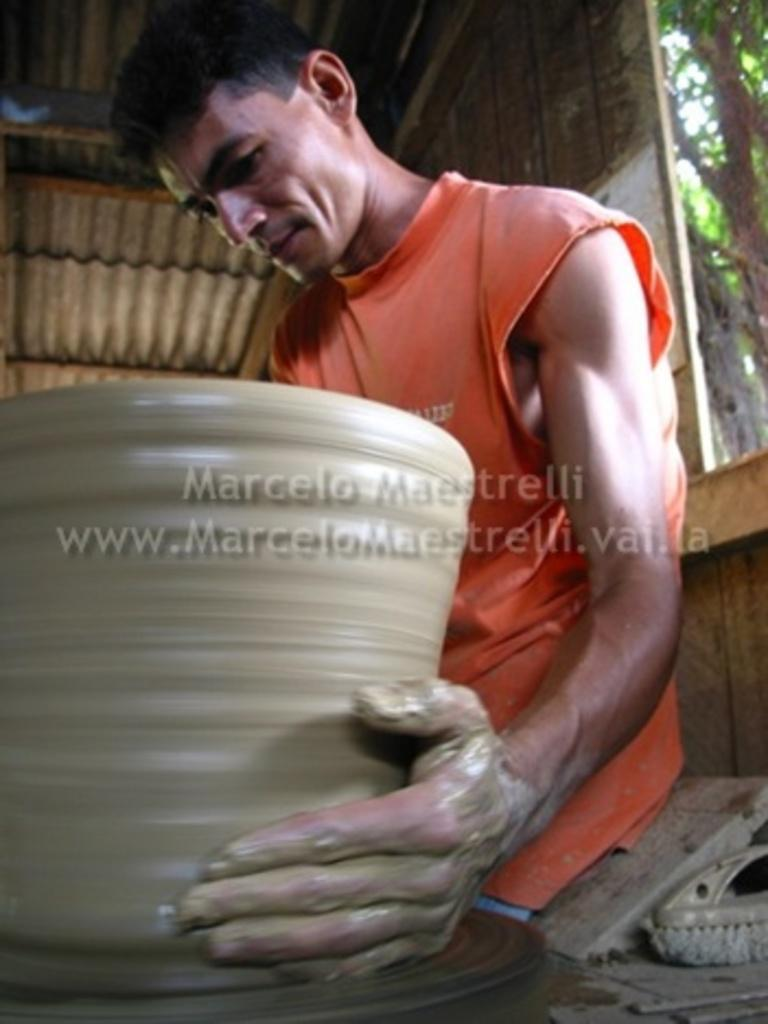Who is present in the image? There is a man in the image. What is the man wearing? The man is wearing an orange T-shirt. What is the man doing in the image? The man is making a pot with mud. What architectural features can be seen in the image? There is a roof and a window visible in the image. What type of vegetation is present in the image? There is a tree on the right side of the image. Can you see the doll's vein in the image? There is no doll or vein present in the image. 